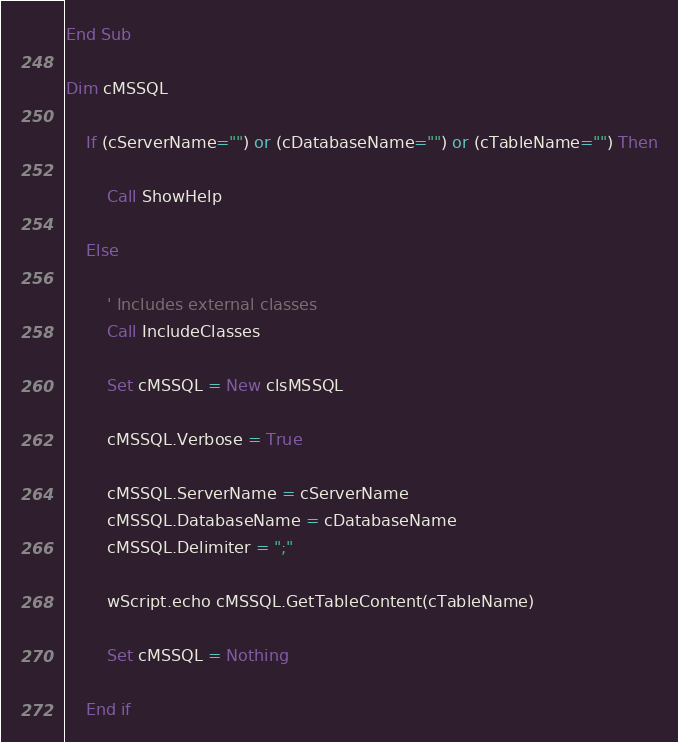<code> <loc_0><loc_0><loc_500><loc_500><_VisualBasic_>End Sub

Dim cMSSQL

	If (cServerName="") or (cDatabaseName="") or (cTableName="") Then

		Call ShowHelp

	Else

		' Includes external classes
		Call IncludeClasses

		Set cMSSQL = New clsMSSQL

		cMSSQL.Verbose = True

		cMSSQL.ServerName = cServerName
		cMSSQL.DatabaseName = cDatabaseName
		cMSSQL.Delimiter = ";"

		wScript.echo cMSSQL.GetTableContent(cTableName)

		Set cMSSQL = Nothing

	End if
</code> 